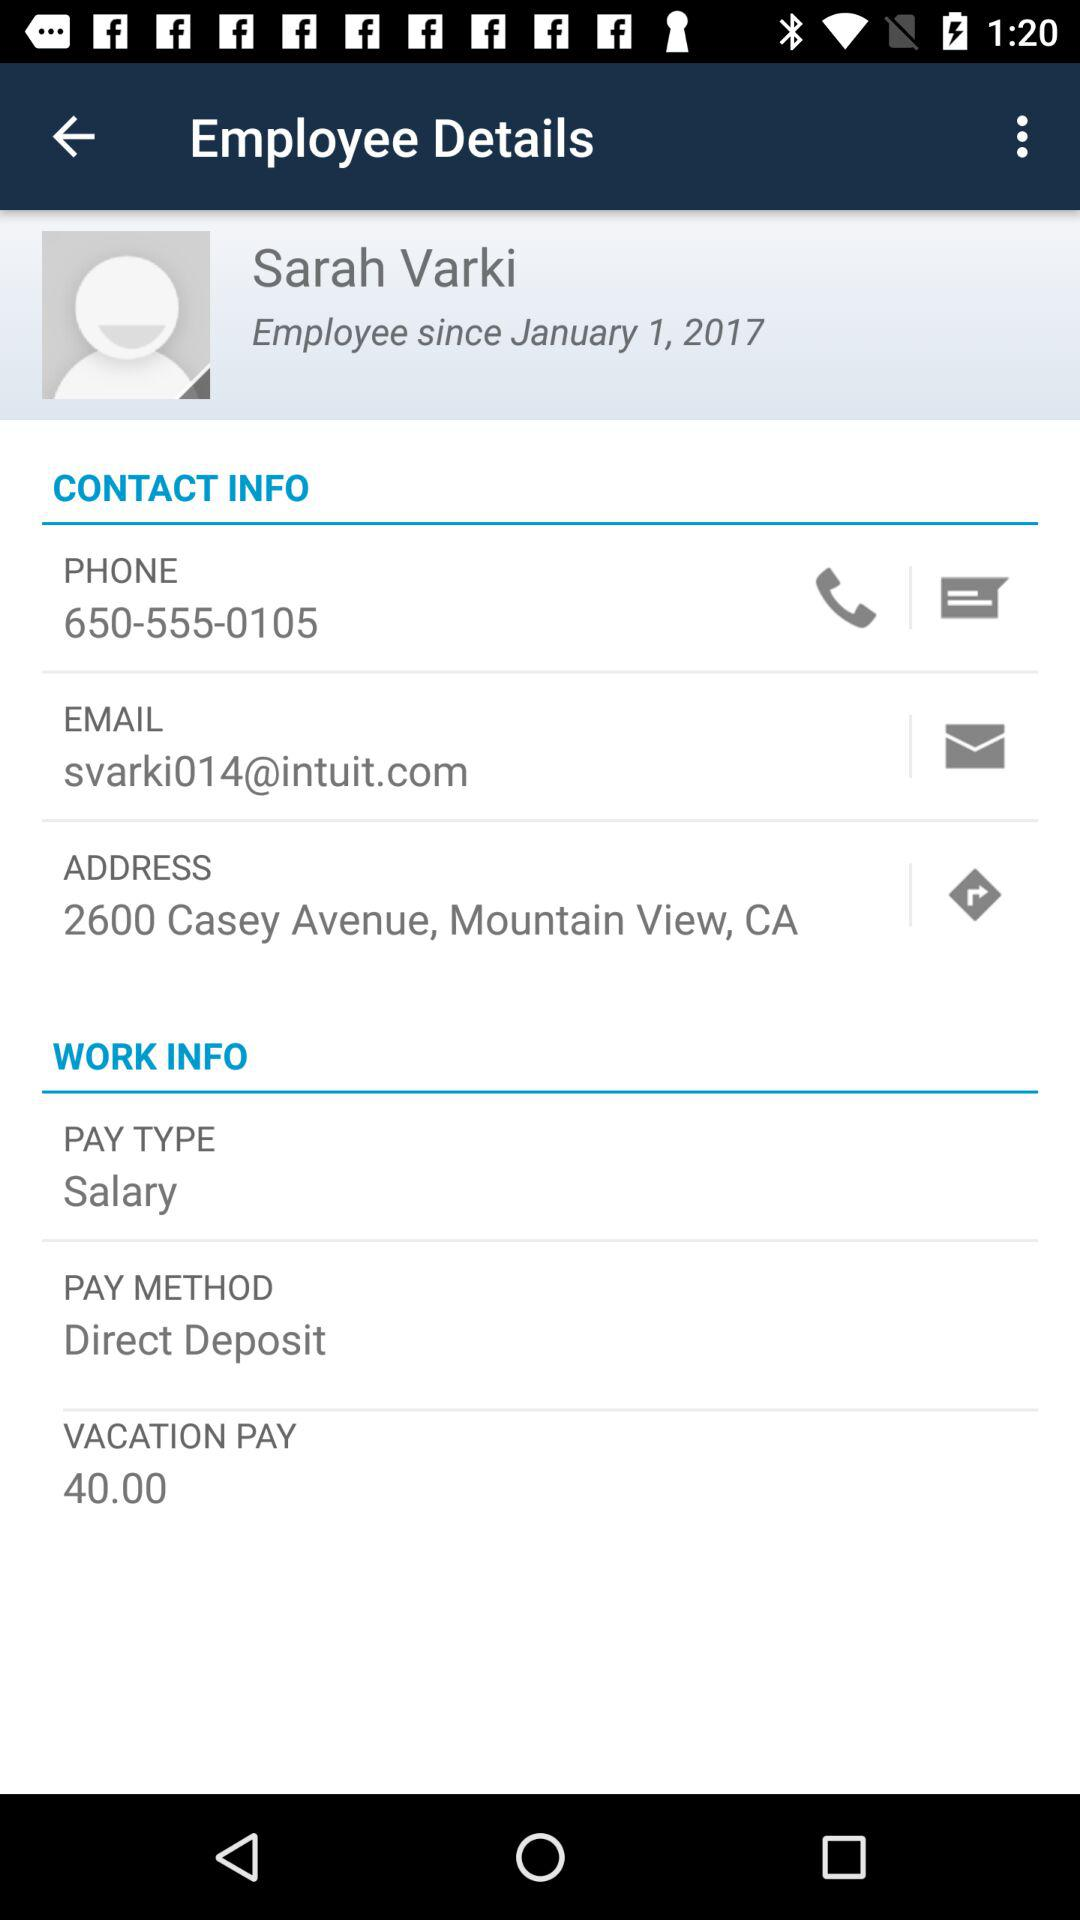What is the address? The address is 2600 Casey Avenue, Mountain View, CA. 